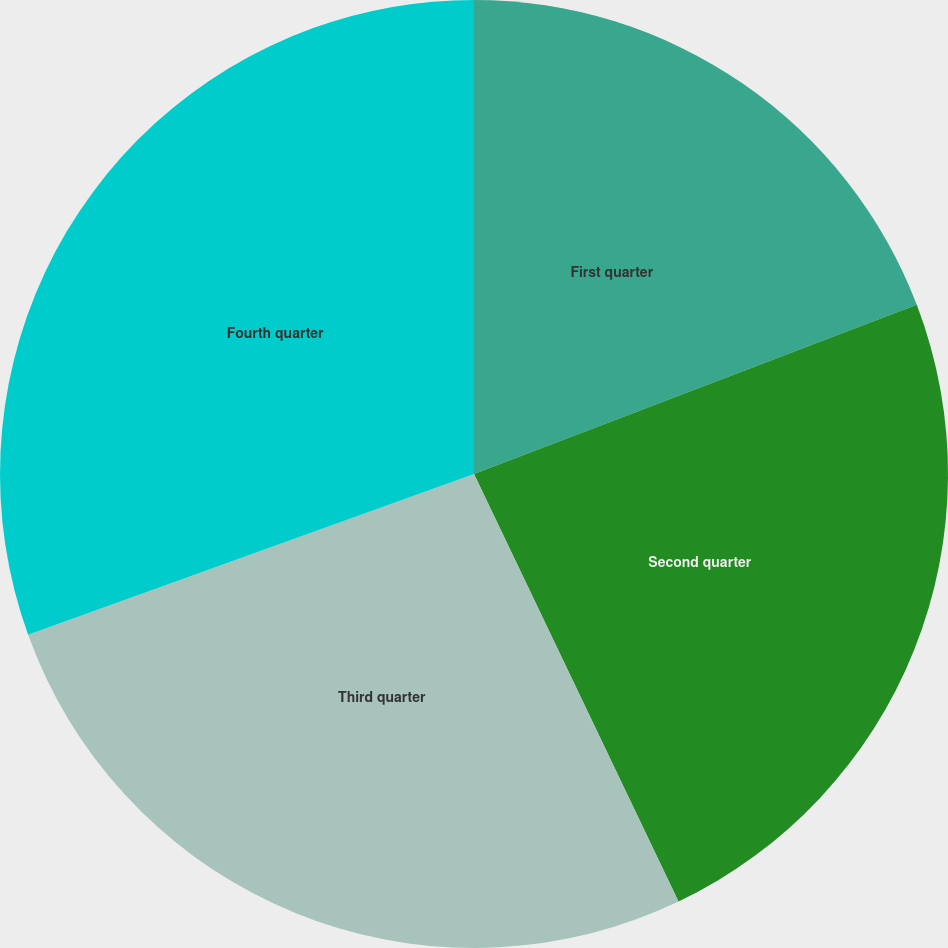<chart> <loc_0><loc_0><loc_500><loc_500><pie_chart><fcel>First quarter<fcel>Second quarter<fcel>Third quarter<fcel>Fourth quarter<nl><fcel>19.19%<fcel>23.71%<fcel>26.59%<fcel>30.51%<nl></chart> 